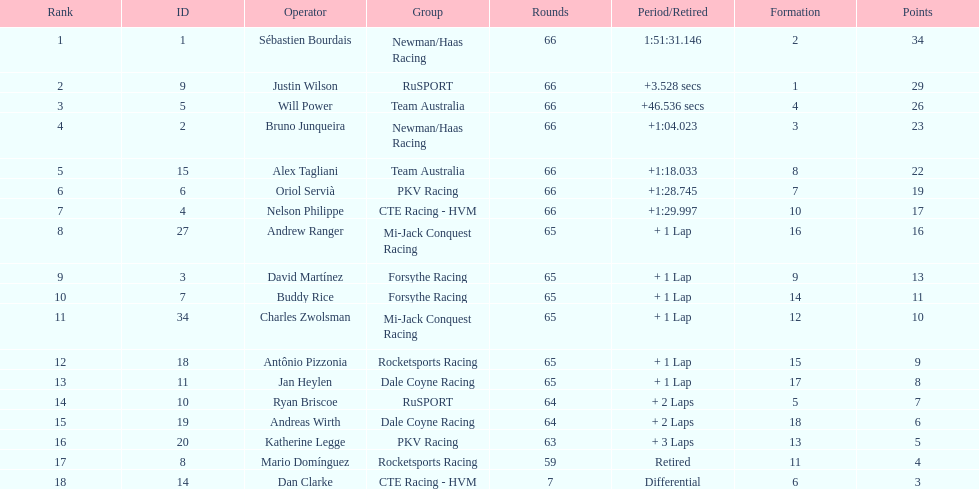At the 2006 gran premio telmex, did oriol servia or katherine legge complete more laps? Oriol Servià. 